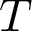Convert formula to latex. <formula><loc_0><loc_0><loc_500><loc_500>T</formula> 